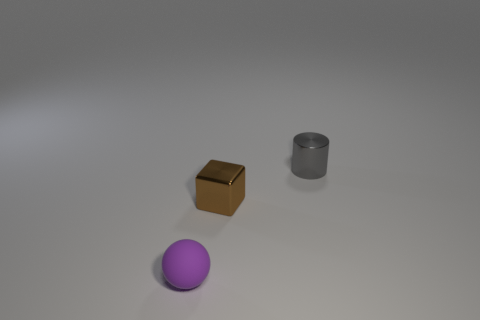Add 1 gray objects. How many objects exist? 4 Subtract all cylinders. How many objects are left? 2 Subtract all big brown metal objects. Subtract all brown cubes. How many objects are left? 2 Add 3 small gray cylinders. How many small gray cylinders are left? 4 Add 2 gray cylinders. How many gray cylinders exist? 3 Subtract 0 green balls. How many objects are left? 3 